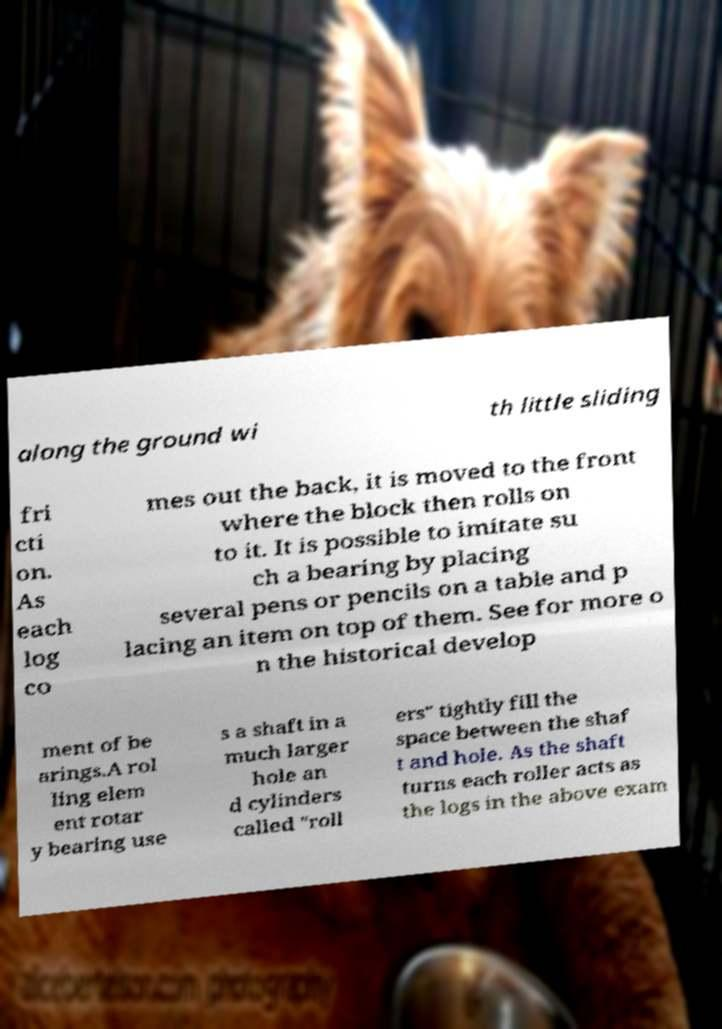Can you accurately transcribe the text from the provided image for me? along the ground wi th little sliding fri cti on. As each log co mes out the back, it is moved to the front where the block then rolls on to it. It is possible to imitate su ch a bearing by placing several pens or pencils on a table and p lacing an item on top of them. See for more o n the historical develop ment of be arings.A rol ling elem ent rotar y bearing use s a shaft in a much larger hole an d cylinders called "roll ers" tightly fill the space between the shaf t and hole. As the shaft turns each roller acts as the logs in the above exam 